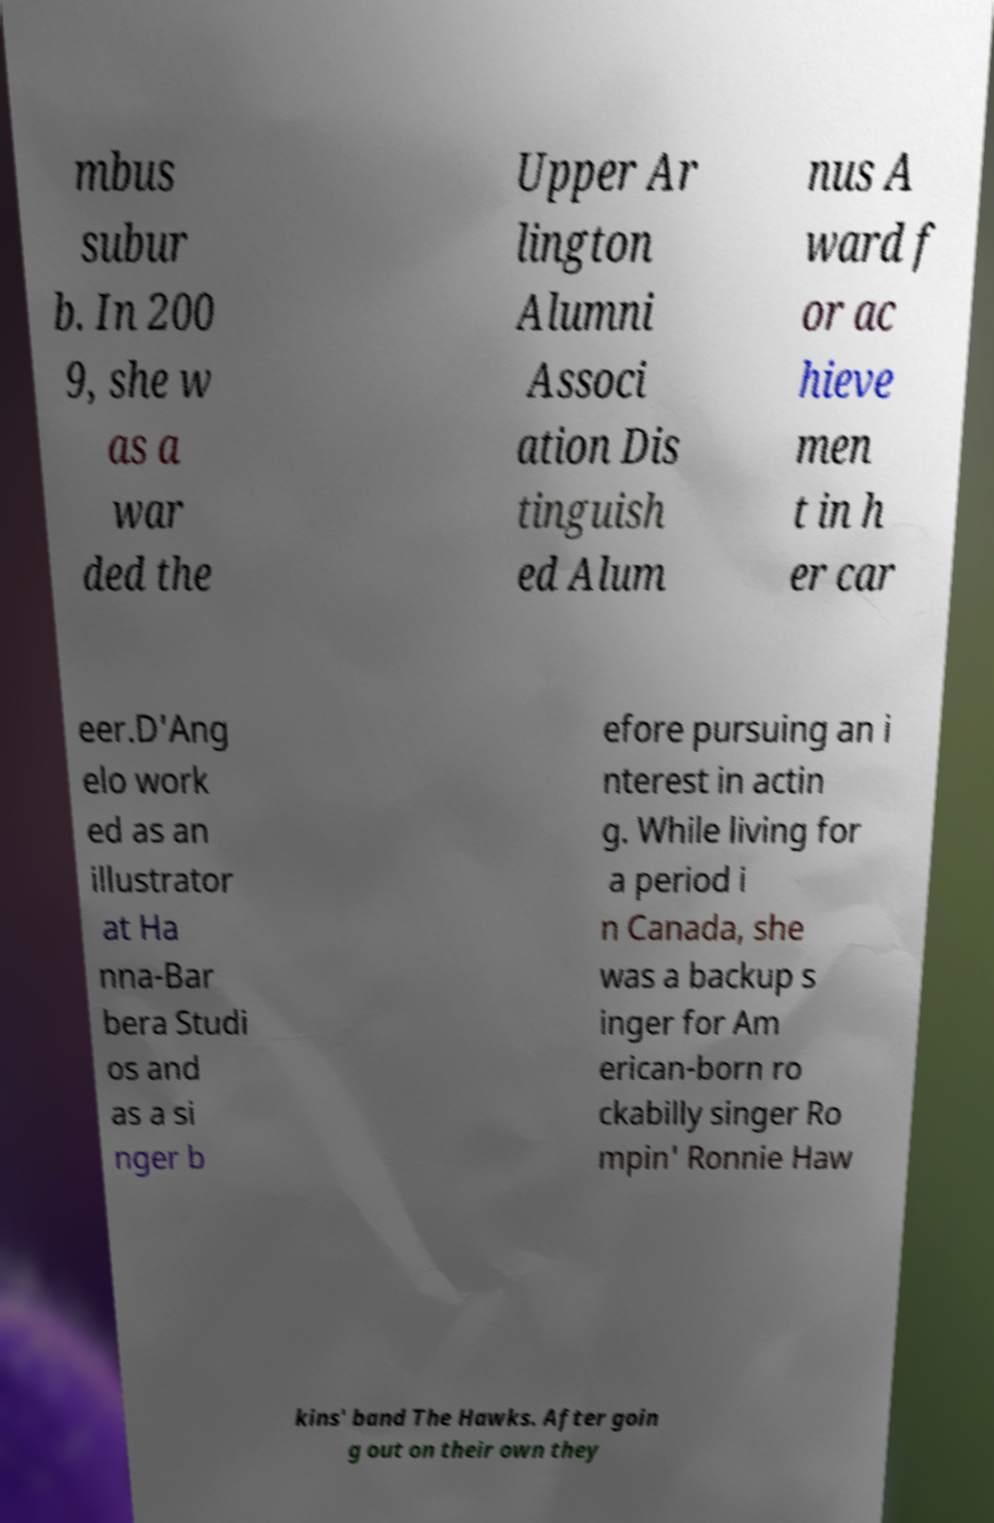For documentation purposes, I need the text within this image transcribed. Could you provide that? mbus subur b. In 200 9, she w as a war ded the Upper Ar lington Alumni Associ ation Dis tinguish ed Alum nus A ward f or ac hieve men t in h er car eer.D'Ang elo work ed as an illustrator at Ha nna-Bar bera Studi os and as a si nger b efore pursuing an i nterest in actin g. While living for a period i n Canada, she was a backup s inger for Am erican-born ro ckabilly singer Ro mpin' Ronnie Haw kins' band The Hawks. After goin g out on their own they 